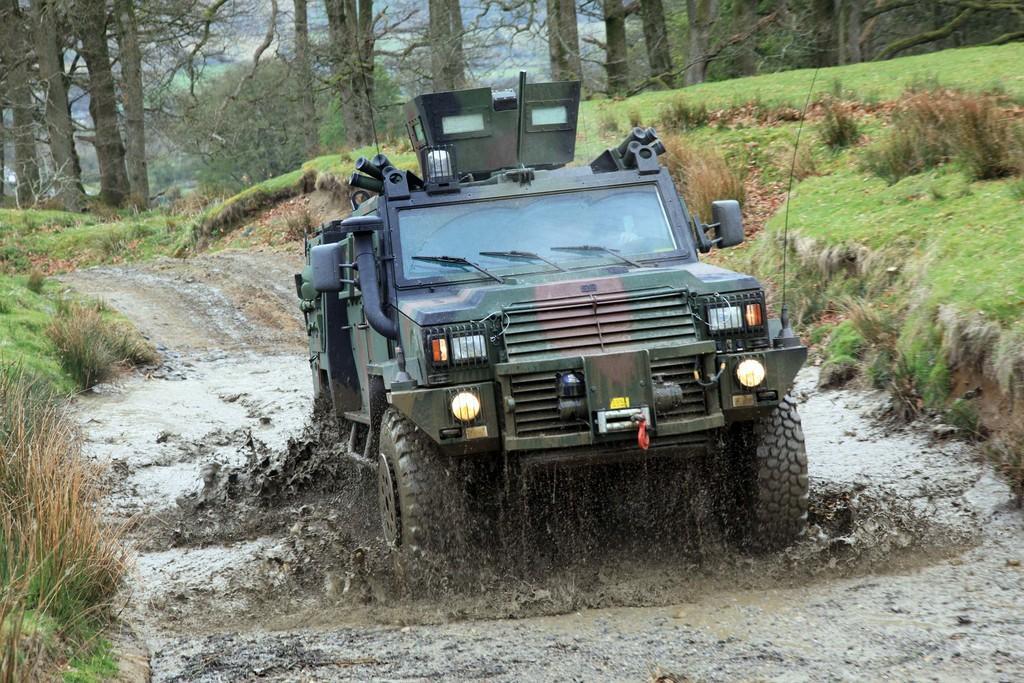Can you describe this image briefly? In this image we can see a vehicle in the mud, there are trees, and the grass. 